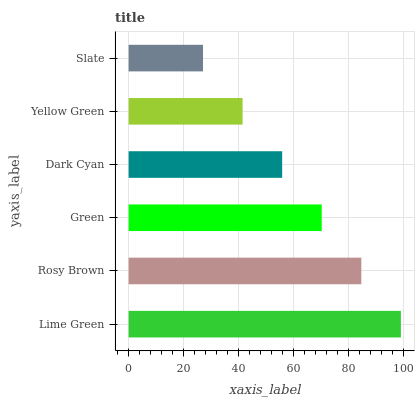Is Slate the minimum?
Answer yes or no. Yes. Is Lime Green the maximum?
Answer yes or no. Yes. Is Rosy Brown the minimum?
Answer yes or no. No. Is Rosy Brown the maximum?
Answer yes or no. No. Is Lime Green greater than Rosy Brown?
Answer yes or no. Yes. Is Rosy Brown less than Lime Green?
Answer yes or no. Yes. Is Rosy Brown greater than Lime Green?
Answer yes or no. No. Is Lime Green less than Rosy Brown?
Answer yes or no. No. Is Green the high median?
Answer yes or no. Yes. Is Dark Cyan the low median?
Answer yes or no. Yes. Is Lime Green the high median?
Answer yes or no. No. Is Rosy Brown the low median?
Answer yes or no. No. 